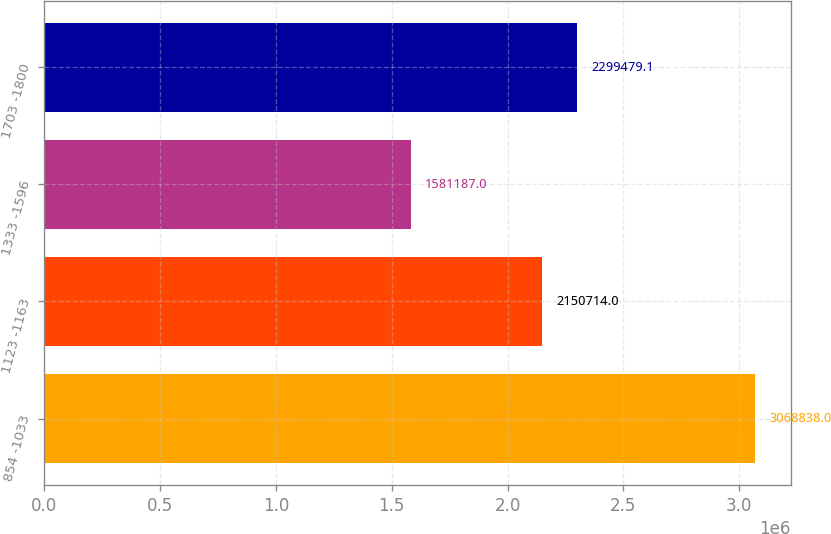<chart> <loc_0><loc_0><loc_500><loc_500><bar_chart><fcel>854 -1033<fcel>1123 -1163<fcel>1333 -1596<fcel>1703 -1800<nl><fcel>3.06884e+06<fcel>2.15071e+06<fcel>1.58119e+06<fcel>2.29948e+06<nl></chart> 